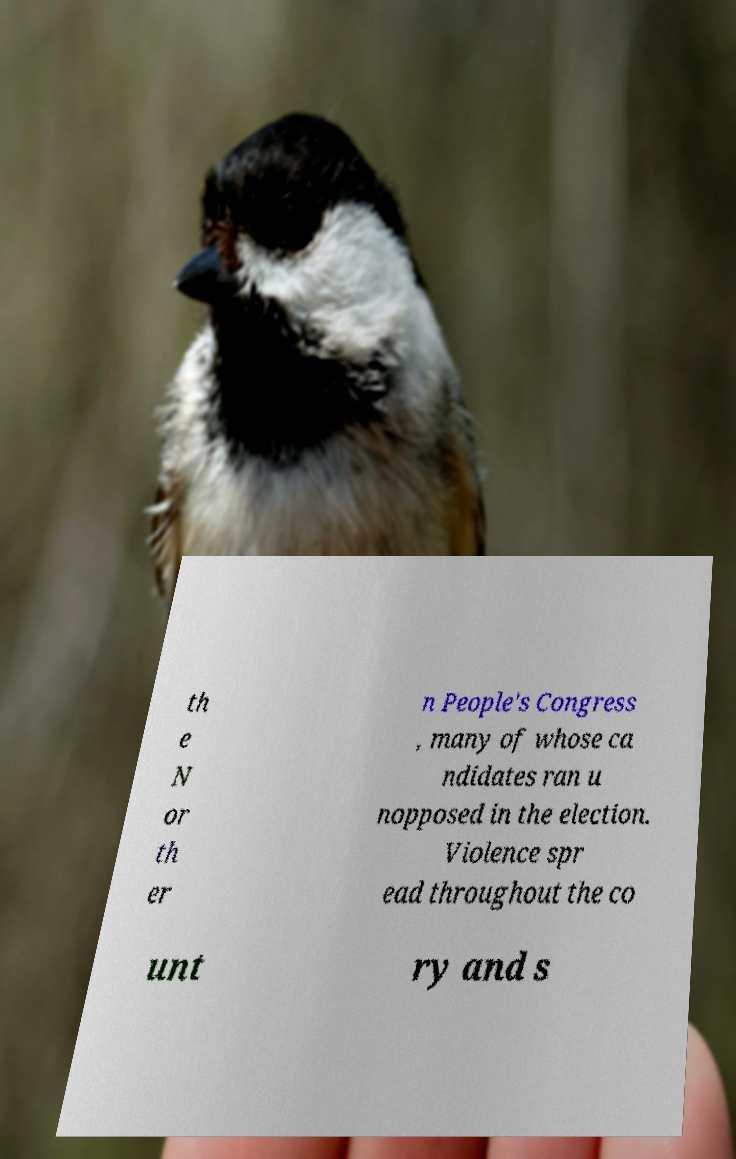Can you accurately transcribe the text from the provided image for me? th e N or th er n People's Congress , many of whose ca ndidates ran u nopposed in the election. Violence spr ead throughout the co unt ry and s 